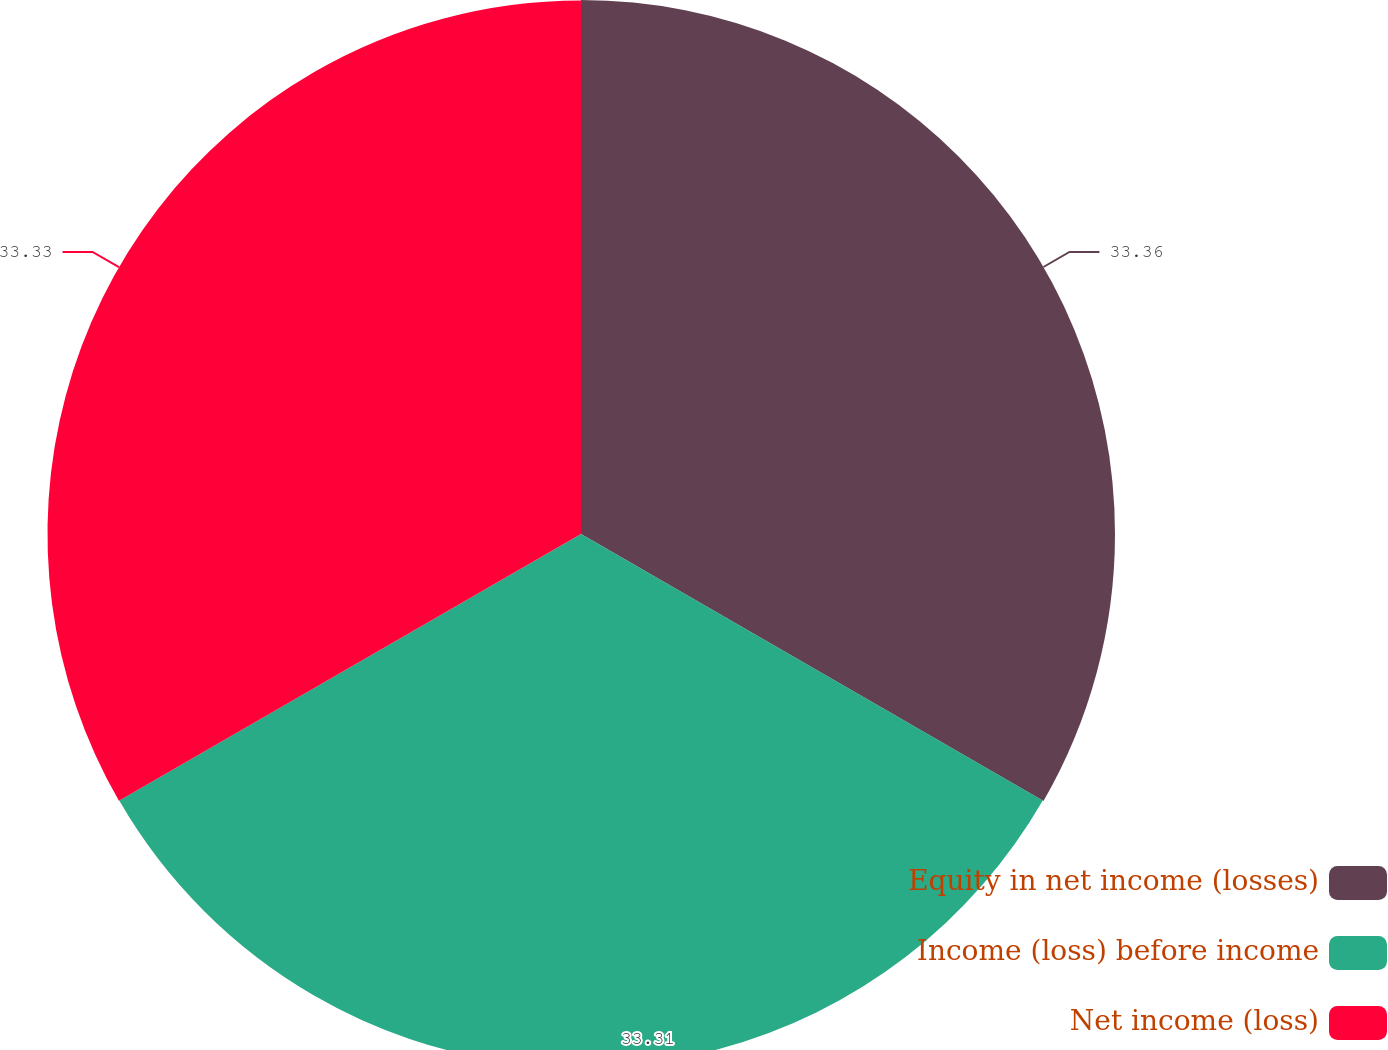Convert chart to OTSL. <chart><loc_0><loc_0><loc_500><loc_500><pie_chart><fcel>Equity in net income (losses)<fcel>Income (loss) before income<fcel>Net income (loss)<nl><fcel>33.36%<fcel>33.31%<fcel>33.33%<nl></chart> 